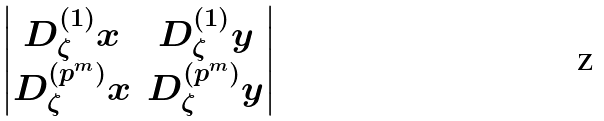<formula> <loc_0><loc_0><loc_500><loc_500>\begin{vmatrix} D _ { \zeta } ^ { ( 1 ) } x & D _ { \zeta } ^ { ( 1 ) } y \\ D _ { \zeta } ^ { ( p ^ { m } ) } x & D _ { \zeta } ^ { ( p ^ { m } ) } y \end{vmatrix}</formula> 